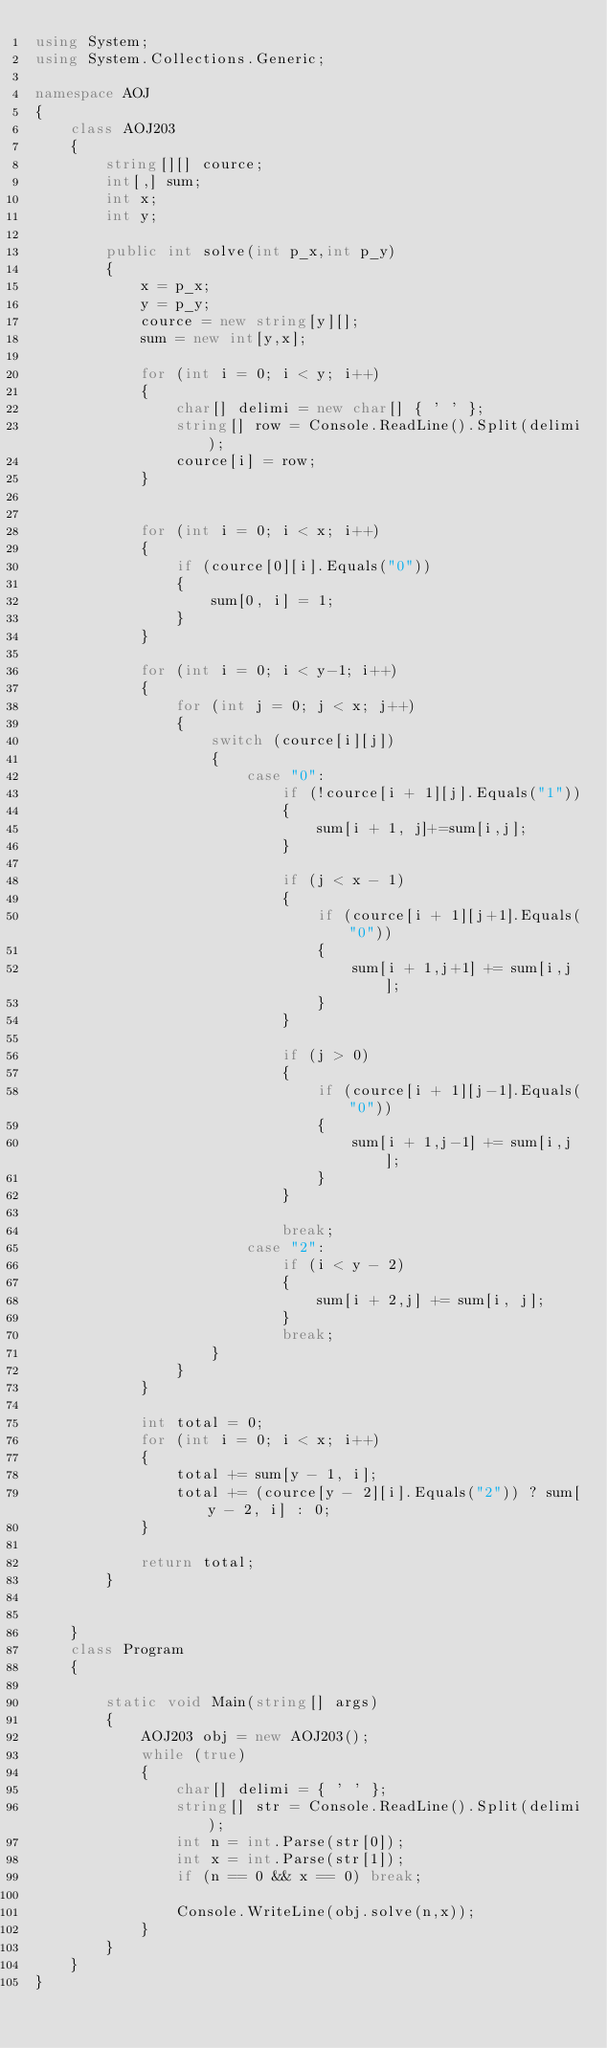<code> <loc_0><loc_0><loc_500><loc_500><_C#_>using System;
using System.Collections.Generic;

namespace AOJ
{
    class AOJ203
    {
        string[][] cource;
        int[,] sum;
        int x;
        int y;

        public int solve(int p_x,int p_y)
        {
            x = p_x;
            y = p_y;
            cource = new string[y][];
            sum = new int[y,x];

            for (int i = 0; i < y; i++)
            {
                char[] delimi = new char[] { ' ' };
                string[] row = Console.ReadLine().Split(delimi);
                cource[i] = row;
            }


            for (int i = 0; i < x; i++)
            {
                if (cource[0][i].Equals("0"))
                {
                    sum[0, i] = 1;
                }
            }

            for (int i = 0; i < y-1; i++)
            {
                for (int j = 0; j < x; j++)
                {
                    switch (cource[i][j])
                    {
                        case "0":
                            if (!cource[i + 1][j].Equals("1"))
                            {
                                sum[i + 1, j]+=sum[i,j];
                            }

                            if (j < x - 1)
                            {
                                if (cource[i + 1][j+1].Equals("0"))
                                {
                                    sum[i + 1,j+1] += sum[i,j];
                                }
                            }

                            if (j > 0)
                            {
                                if (cource[i + 1][j-1].Equals("0"))
                                {
                                    sum[i + 1,j-1] += sum[i,j];
                                }
                            }

                            break;
                        case "2":
                            if (i < y - 2)
                            {
                                sum[i + 2,j] += sum[i, j];
                            }
                            break;
                    }
                }
            }

            int total = 0;
            for (int i = 0; i < x; i++)
            {
                total += sum[y - 1, i];
                total += (cource[y - 2][i].Equals("2")) ? sum[y - 2, i] : 0;
            }

            return total;
        }
        
        
    }
    class Program
    {
        
        static void Main(string[] args)
        {
            AOJ203 obj = new AOJ203();
            while (true)
            {
                char[] delimi = { ' ' };
                string[] str = Console.ReadLine().Split(delimi);
                int n = int.Parse(str[0]);
                int x = int.Parse(str[1]);
                if (n == 0 && x == 0) break;

                Console.WriteLine(obj.solve(n,x));
            }
        }
    }
}</code> 